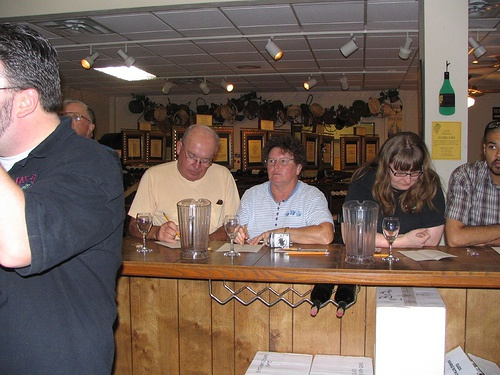Describe the objects in this image and their specific colors. I can see people in gray, black, and white tones, people in gray, black, and maroon tones, people in gray, tan, brown, and maroon tones, people in gray, brown, lavender, darkgray, and black tones, and people in gray, darkgray, and black tones in this image. 